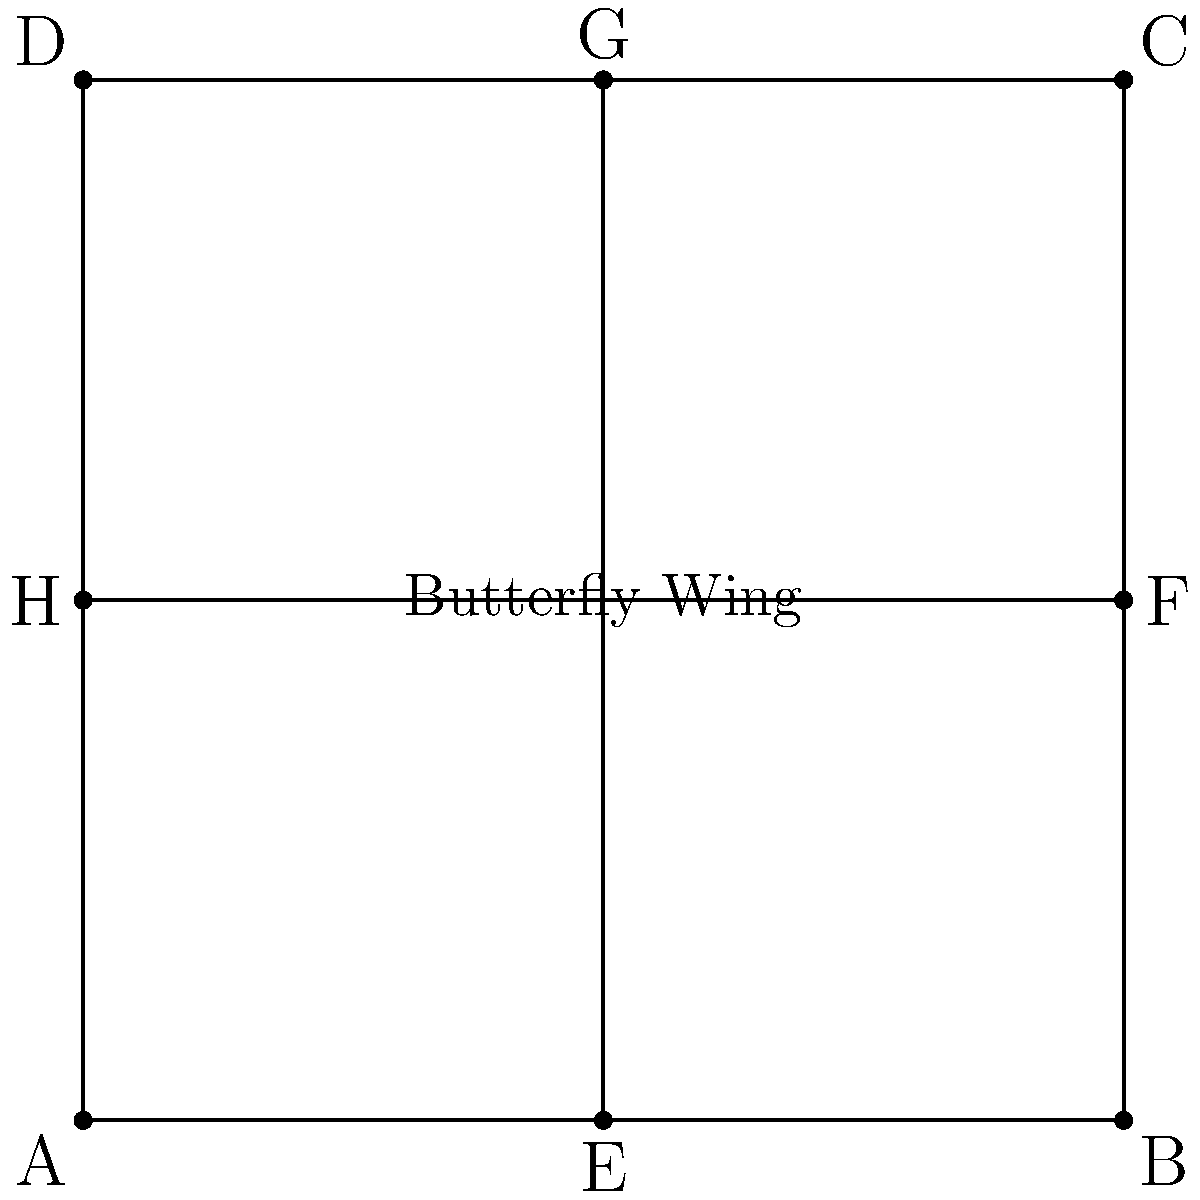As a member of Citizens for Animal Protection, you're studying butterfly wing symmetry. The diagram represents a simplified butterfly wing using geometric shapes. How many lines of symmetry does this shape have, and what type of symmetry does it exhibit? Explain how this relates to real butterfly wings and their importance in nature. Let's analyze the symmetry of the given shape step-by-step:

1. Lines of symmetry:
   a) Vertical line: The shape is symmetric about the vertical line passing through points E and G.
   b) Horizontal line: The shape is symmetric about the horizontal line passing through points H and F.
   c) Diagonal lines: The shape is also symmetric about both diagonals (AC and BD).

2. Type of symmetry:
   This shape exhibits rotational symmetry of order 4, meaning it can be rotated 90°, 180°, 270°, and 360° (full rotation) about its center, and it will appear the same.

3. Relation to real butterfly wings:
   a) Bilateral symmetry: Real butterfly wings typically have bilateral symmetry, which is represented by the vertical line of symmetry in our diagram. This symmetry is crucial for balanced flight.
   b) Patterns: The additional lines of symmetry in our diagram (horizontal and diagonal) represent the complex patterns often found on butterfly wings, which can have multiple axes of symmetry within their intricate designs.

4. Importance in nature:
   a) Flight efficiency: The symmetry of butterfly wings allows for balanced and efficient flight, which is essential for survival, feeding, and mating.
   b) Camouflage and warning signals: Symmetric patterns can help butterflies blend into their environment or warn predators of their toxicity.
   c) Mate attraction: Symmetrical wing patterns are often indicators of genetic fitness, playing a role in mate selection.
   d) Thermoregulation: Symmetrical wings help butterflies regulate their body temperature evenly.

Understanding and protecting these intricate designs is crucial for butterfly conservation efforts.
Answer: 4 lines of symmetry; rotational symmetry of order 4. 